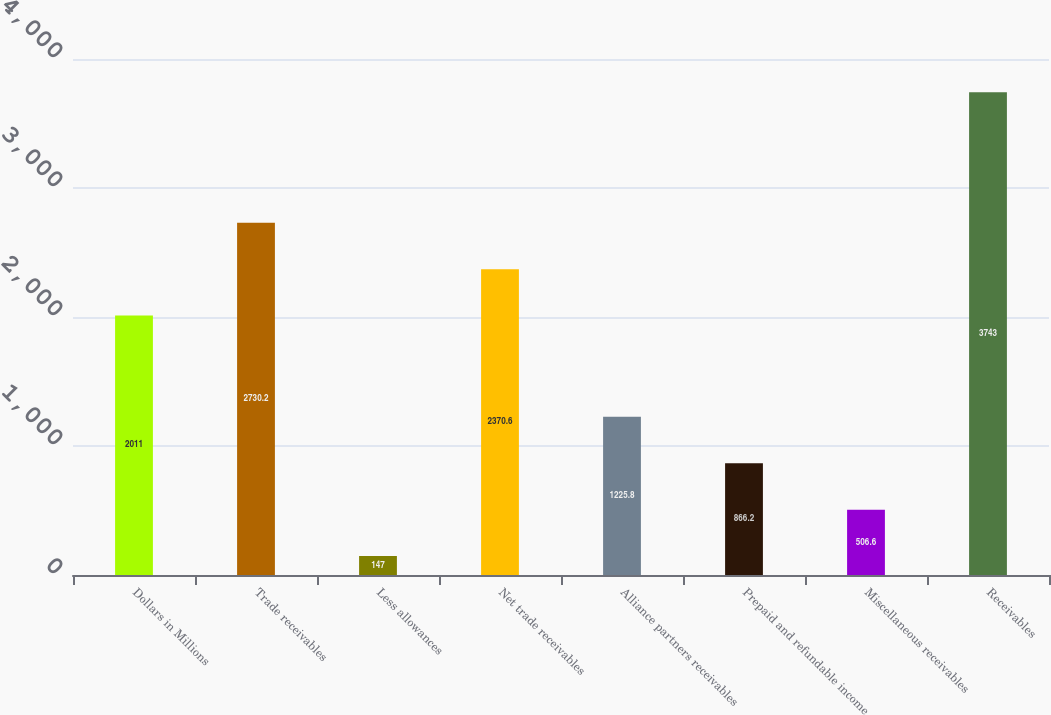Convert chart to OTSL. <chart><loc_0><loc_0><loc_500><loc_500><bar_chart><fcel>Dollars in Millions<fcel>Trade receivables<fcel>Less allowances<fcel>Net trade receivables<fcel>Alliance partners receivables<fcel>Prepaid and refundable income<fcel>Miscellaneous receivables<fcel>Receivables<nl><fcel>2011<fcel>2730.2<fcel>147<fcel>2370.6<fcel>1225.8<fcel>866.2<fcel>506.6<fcel>3743<nl></chart> 